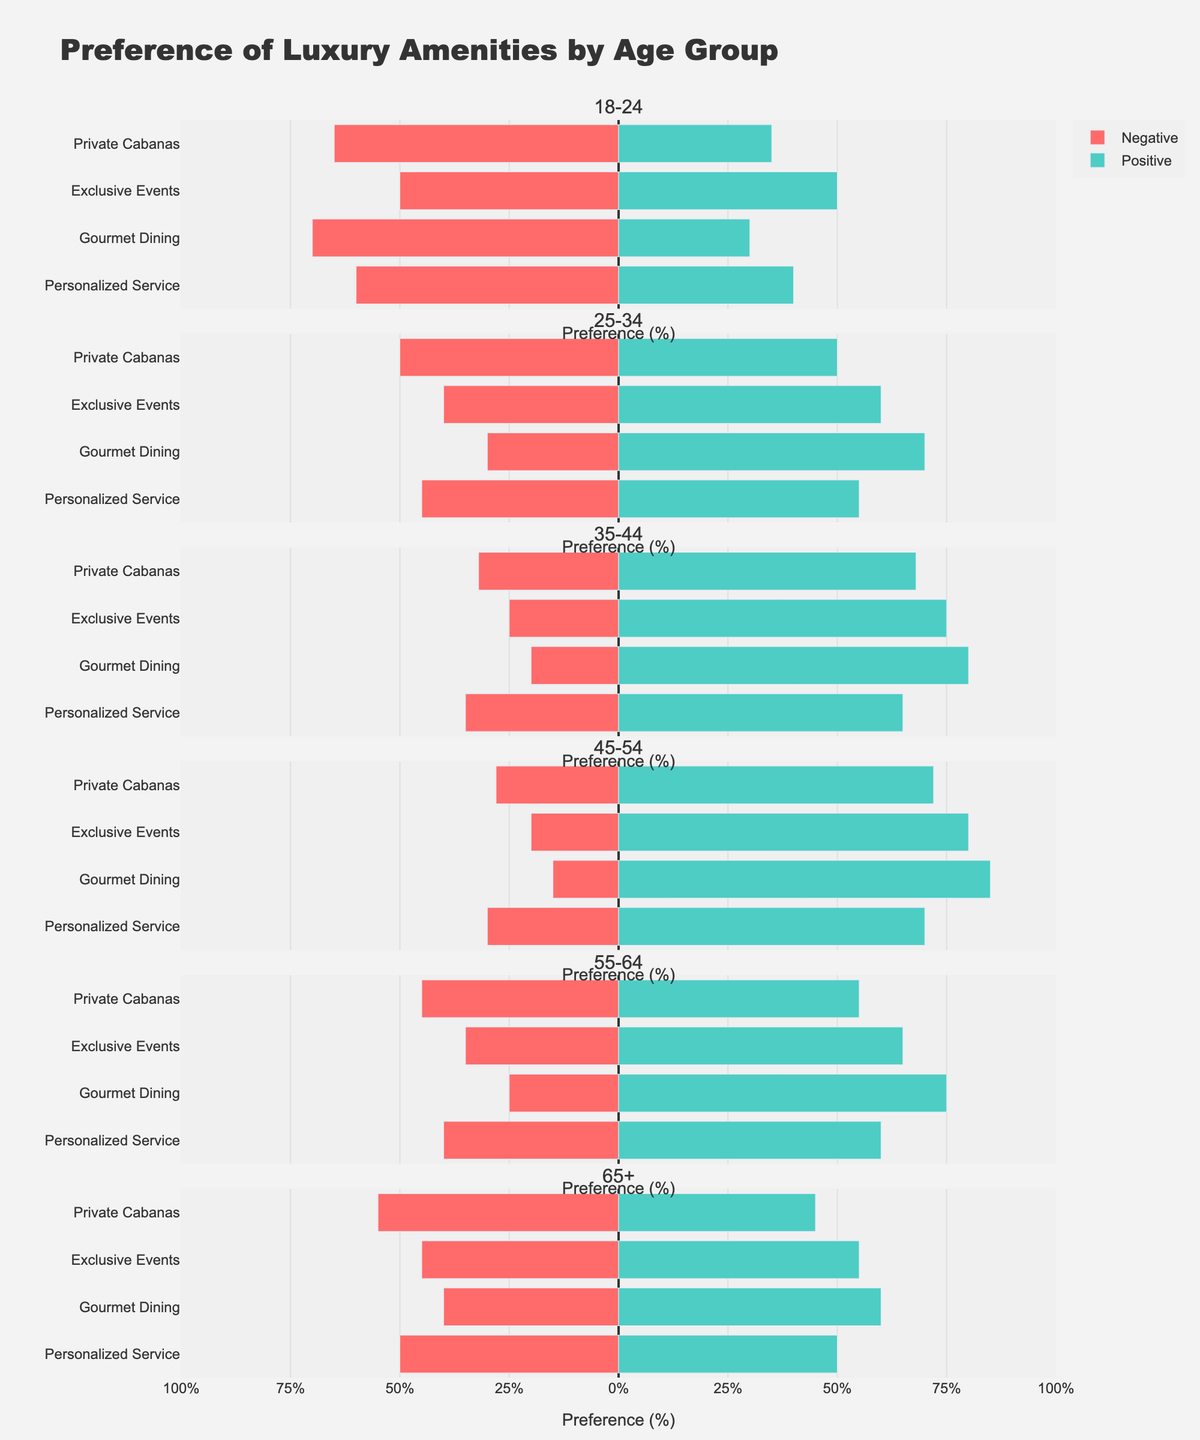Which age group has the highest positive preference for Gourmet Dining? The visual representation for Gourmet Dining shows that the 45-54 age group has the longest green bar, indicating the highest positive preference.
Answer: 45-54 How does the negative preference for Private Cabanas in the 65+ age group compare to the positive preference in the same group? For the 65+ age group, the negative preference for Private Cabanas is about 55%, while the positive preference is about 45%. This shows that the negative preference is higher.
Answer: Negative preference is higher Which amenity has the most balanced preference (positive and negative being equal) in the 18-24 age group? In the 18-24 age group, Exclusive Events has both positive and negative preferences at 50%, showing balance.
Answer: Exclusive Events What's the difference in the positive preference for Personalized Service between the 25-34 and 45-54 age groups? The positive preference for Personalized Service is 55% in the 25-34 age group and 70% in the 45-54 age group. The difference is 70% - 55% = 15%.
Answer: 15% Which age group has the least negative preference for Gourmet Dining? The visual representation shows that the 45-54 age group has the shortest red bar for Gourmet Dining, indicating the least negative preference.
Answer: 45-54 What is the sum of positive preferences for Exclusive Events in the 25-34 and 35-44 age groups? For the 25-34 age group, the positive preference for Exclusive Events is 60%, and for the 35-44 age group, it is 75%. The sum is 60% + 75% = 135%.
Answer: 135% Compare the positive and negative preferences for Personalized Service in the 35-44 age group. The positive preference for Personalized Service in the 35-44 age group is 65%, and the negative preference is 35%.
Answer: Positive is higher Which age group has the highest negative preference for Private Cabanas? The 18-24 age group shows the longest red bar for Private Cabanas, indicating the highest negative preference.
Answer: 18-24 What is the average positive preference for Gourmet Dining across all age groups? The positive preferences for Gourmet Dining by age group are 30%, 70%, 80%, 85%, 75%, and 60%. The average is (30% + 70% + 80% + 85% + 75% + 60%) / 6 = 66.67%.
Answer: 66.67% How does the positive preference for Exclusive Events in the 55-64 age group compare to the 65+ age group? The positive preference for Exclusive Events is 65% in the 55-64 age group and 55% in the 65+ age group, showing a higher preference in the 55-64 age group.
Answer: Higher in 55-64 